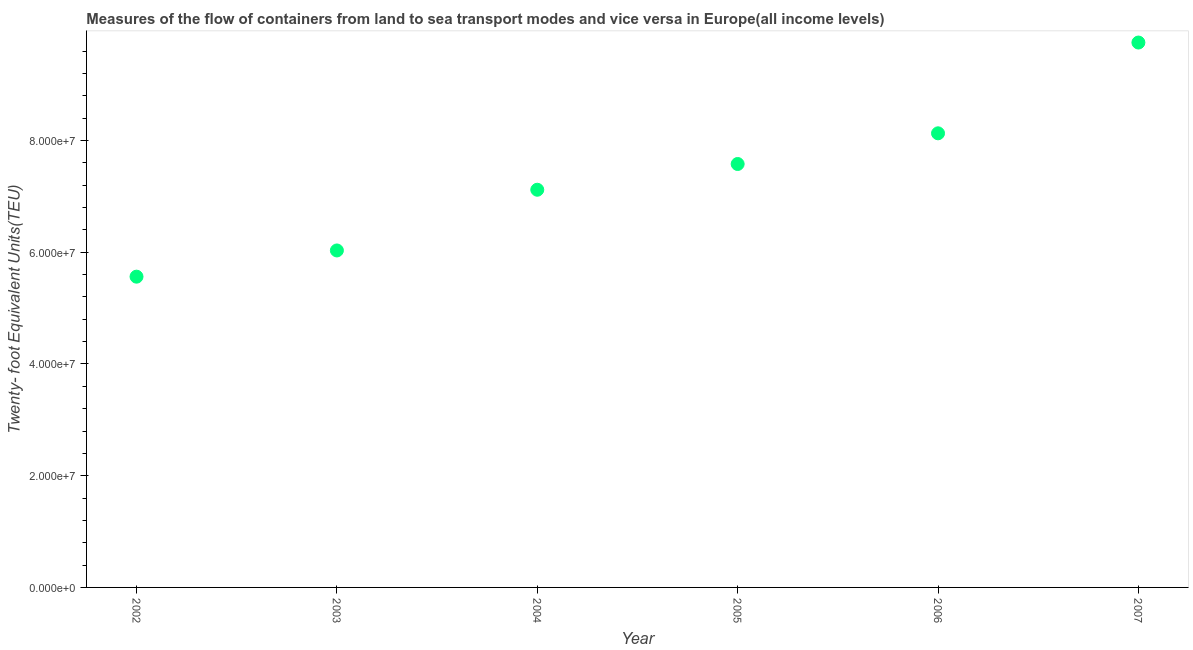What is the container port traffic in 2005?
Keep it short and to the point. 7.58e+07. Across all years, what is the maximum container port traffic?
Your response must be concise. 9.75e+07. Across all years, what is the minimum container port traffic?
Your answer should be very brief. 5.56e+07. In which year was the container port traffic maximum?
Provide a succinct answer. 2007. What is the sum of the container port traffic?
Ensure brevity in your answer.  4.42e+08. What is the difference between the container port traffic in 2004 and 2006?
Provide a short and direct response. -1.01e+07. What is the average container port traffic per year?
Ensure brevity in your answer.  7.36e+07. What is the median container port traffic?
Provide a short and direct response. 7.35e+07. In how many years, is the container port traffic greater than 64000000 TEU?
Provide a succinct answer. 4. Do a majority of the years between 2002 and 2004 (inclusive) have container port traffic greater than 76000000 TEU?
Offer a terse response. No. What is the ratio of the container port traffic in 2003 to that in 2006?
Give a very brief answer. 0.74. Is the container port traffic in 2002 less than that in 2004?
Ensure brevity in your answer.  Yes. Is the difference between the container port traffic in 2002 and 2006 greater than the difference between any two years?
Ensure brevity in your answer.  No. What is the difference between the highest and the second highest container port traffic?
Your response must be concise. 1.63e+07. Is the sum of the container port traffic in 2002 and 2005 greater than the maximum container port traffic across all years?
Provide a succinct answer. Yes. What is the difference between the highest and the lowest container port traffic?
Your answer should be compact. 4.19e+07. In how many years, is the container port traffic greater than the average container port traffic taken over all years?
Your answer should be compact. 3. How many dotlines are there?
Your answer should be very brief. 1. How many years are there in the graph?
Offer a very short reply. 6. Are the values on the major ticks of Y-axis written in scientific E-notation?
Offer a very short reply. Yes. What is the title of the graph?
Offer a very short reply. Measures of the flow of containers from land to sea transport modes and vice versa in Europe(all income levels). What is the label or title of the X-axis?
Provide a short and direct response. Year. What is the label or title of the Y-axis?
Offer a terse response. Twenty- foot Equivalent Units(TEU). What is the Twenty- foot Equivalent Units(TEU) in 2002?
Make the answer very short. 5.56e+07. What is the Twenty- foot Equivalent Units(TEU) in 2003?
Ensure brevity in your answer.  6.03e+07. What is the Twenty- foot Equivalent Units(TEU) in 2004?
Ensure brevity in your answer.  7.12e+07. What is the Twenty- foot Equivalent Units(TEU) in 2005?
Provide a short and direct response. 7.58e+07. What is the Twenty- foot Equivalent Units(TEU) in 2006?
Your response must be concise. 8.13e+07. What is the Twenty- foot Equivalent Units(TEU) in 2007?
Provide a short and direct response. 9.75e+07. What is the difference between the Twenty- foot Equivalent Units(TEU) in 2002 and 2003?
Your response must be concise. -4.69e+06. What is the difference between the Twenty- foot Equivalent Units(TEU) in 2002 and 2004?
Keep it short and to the point. -1.56e+07. What is the difference between the Twenty- foot Equivalent Units(TEU) in 2002 and 2005?
Offer a terse response. -2.02e+07. What is the difference between the Twenty- foot Equivalent Units(TEU) in 2002 and 2006?
Give a very brief answer. -2.57e+07. What is the difference between the Twenty- foot Equivalent Units(TEU) in 2002 and 2007?
Offer a very short reply. -4.19e+07. What is the difference between the Twenty- foot Equivalent Units(TEU) in 2003 and 2004?
Keep it short and to the point. -1.09e+07. What is the difference between the Twenty- foot Equivalent Units(TEU) in 2003 and 2005?
Ensure brevity in your answer.  -1.55e+07. What is the difference between the Twenty- foot Equivalent Units(TEU) in 2003 and 2006?
Your answer should be very brief. -2.10e+07. What is the difference between the Twenty- foot Equivalent Units(TEU) in 2003 and 2007?
Offer a terse response. -3.72e+07. What is the difference between the Twenty- foot Equivalent Units(TEU) in 2004 and 2005?
Make the answer very short. -4.61e+06. What is the difference between the Twenty- foot Equivalent Units(TEU) in 2004 and 2006?
Keep it short and to the point. -1.01e+07. What is the difference between the Twenty- foot Equivalent Units(TEU) in 2004 and 2007?
Provide a short and direct response. -2.64e+07. What is the difference between the Twenty- foot Equivalent Units(TEU) in 2005 and 2006?
Ensure brevity in your answer.  -5.49e+06. What is the difference between the Twenty- foot Equivalent Units(TEU) in 2005 and 2007?
Your answer should be very brief. -2.17e+07. What is the difference between the Twenty- foot Equivalent Units(TEU) in 2006 and 2007?
Your answer should be very brief. -1.63e+07. What is the ratio of the Twenty- foot Equivalent Units(TEU) in 2002 to that in 2003?
Provide a succinct answer. 0.92. What is the ratio of the Twenty- foot Equivalent Units(TEU) in 2002 to that in 2004?
Offer a very short reply. 0.78. What is the ratio of the Twenty- foot Equivalent Units(TEU) in 2002 to that in 2005?
Your answer should be compact. 0.73. What is the ratio of the Twenty- foot Equivalent Units(TEU) in 2002 to that in 2006?
Your response must be concise. 0.68. What is the ratio of the Twenty- foot Equivalent Units(TEU) in 2002 to that in 2007?
Give a very brief answer. 0.57. What is the ratio of the Twenty- foot Equivalent Units(TEU) in 2003 to that in 2004?
Provide a short and direct response. 0.85. What is the ratio of the Twenty- foot Equivalent Units(TEU) in 2003 to that in 2005?
Keep it short and to the point. 0.8. What is the ratio of the Twenty- foot Equivalent Units(TEU) in 2003 to that in 2006?
Offer a very short reply. 0.74. What is the ratio of the Twenty- foot Equivalent Units(TEU) in 2003 to that in 2007?
Your answer should be very brief. 0.62. What is the ratio of the Twenty- foot Equivalent Units(TEU) in 2004 to that in 2005?
Keep it short and to the point. 0.94. What is the ratio of the Twenty- foot Equivalent Units(TEU) in 2004 to that in 2006?
Give a very brief answer. 0.88. What is the ratio of the Twenty- foot Equivalent Units(TEU) in 2004 to that in 2007?
Provide a succinct answer. 0.73. What is the ratio of the Twenty- foot Equivalent Units(TEU) in 2005 to that in 2006?
Your response must be concise. 0.93. What is the ratio of the Twenty- foot Equivalent Units(TEU) in 2005 to that in 2007?
Your response must be concise. 0.78. What is the ratio of the Twenty- foot Equivalent Units(TEU) in 2006 to that in 2007?
Make the answer very short. 0.83. 